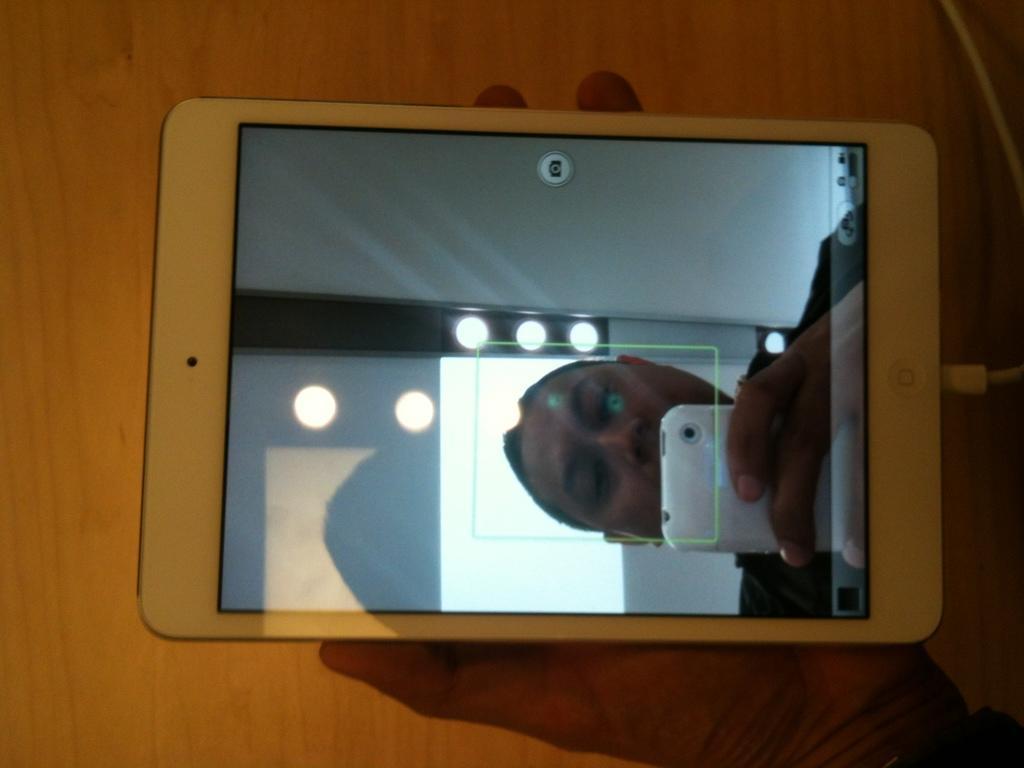In one or two sentences, can you explain what this image depicts? In this image we can see a man holding mobile phone in his hand on the display screen. 